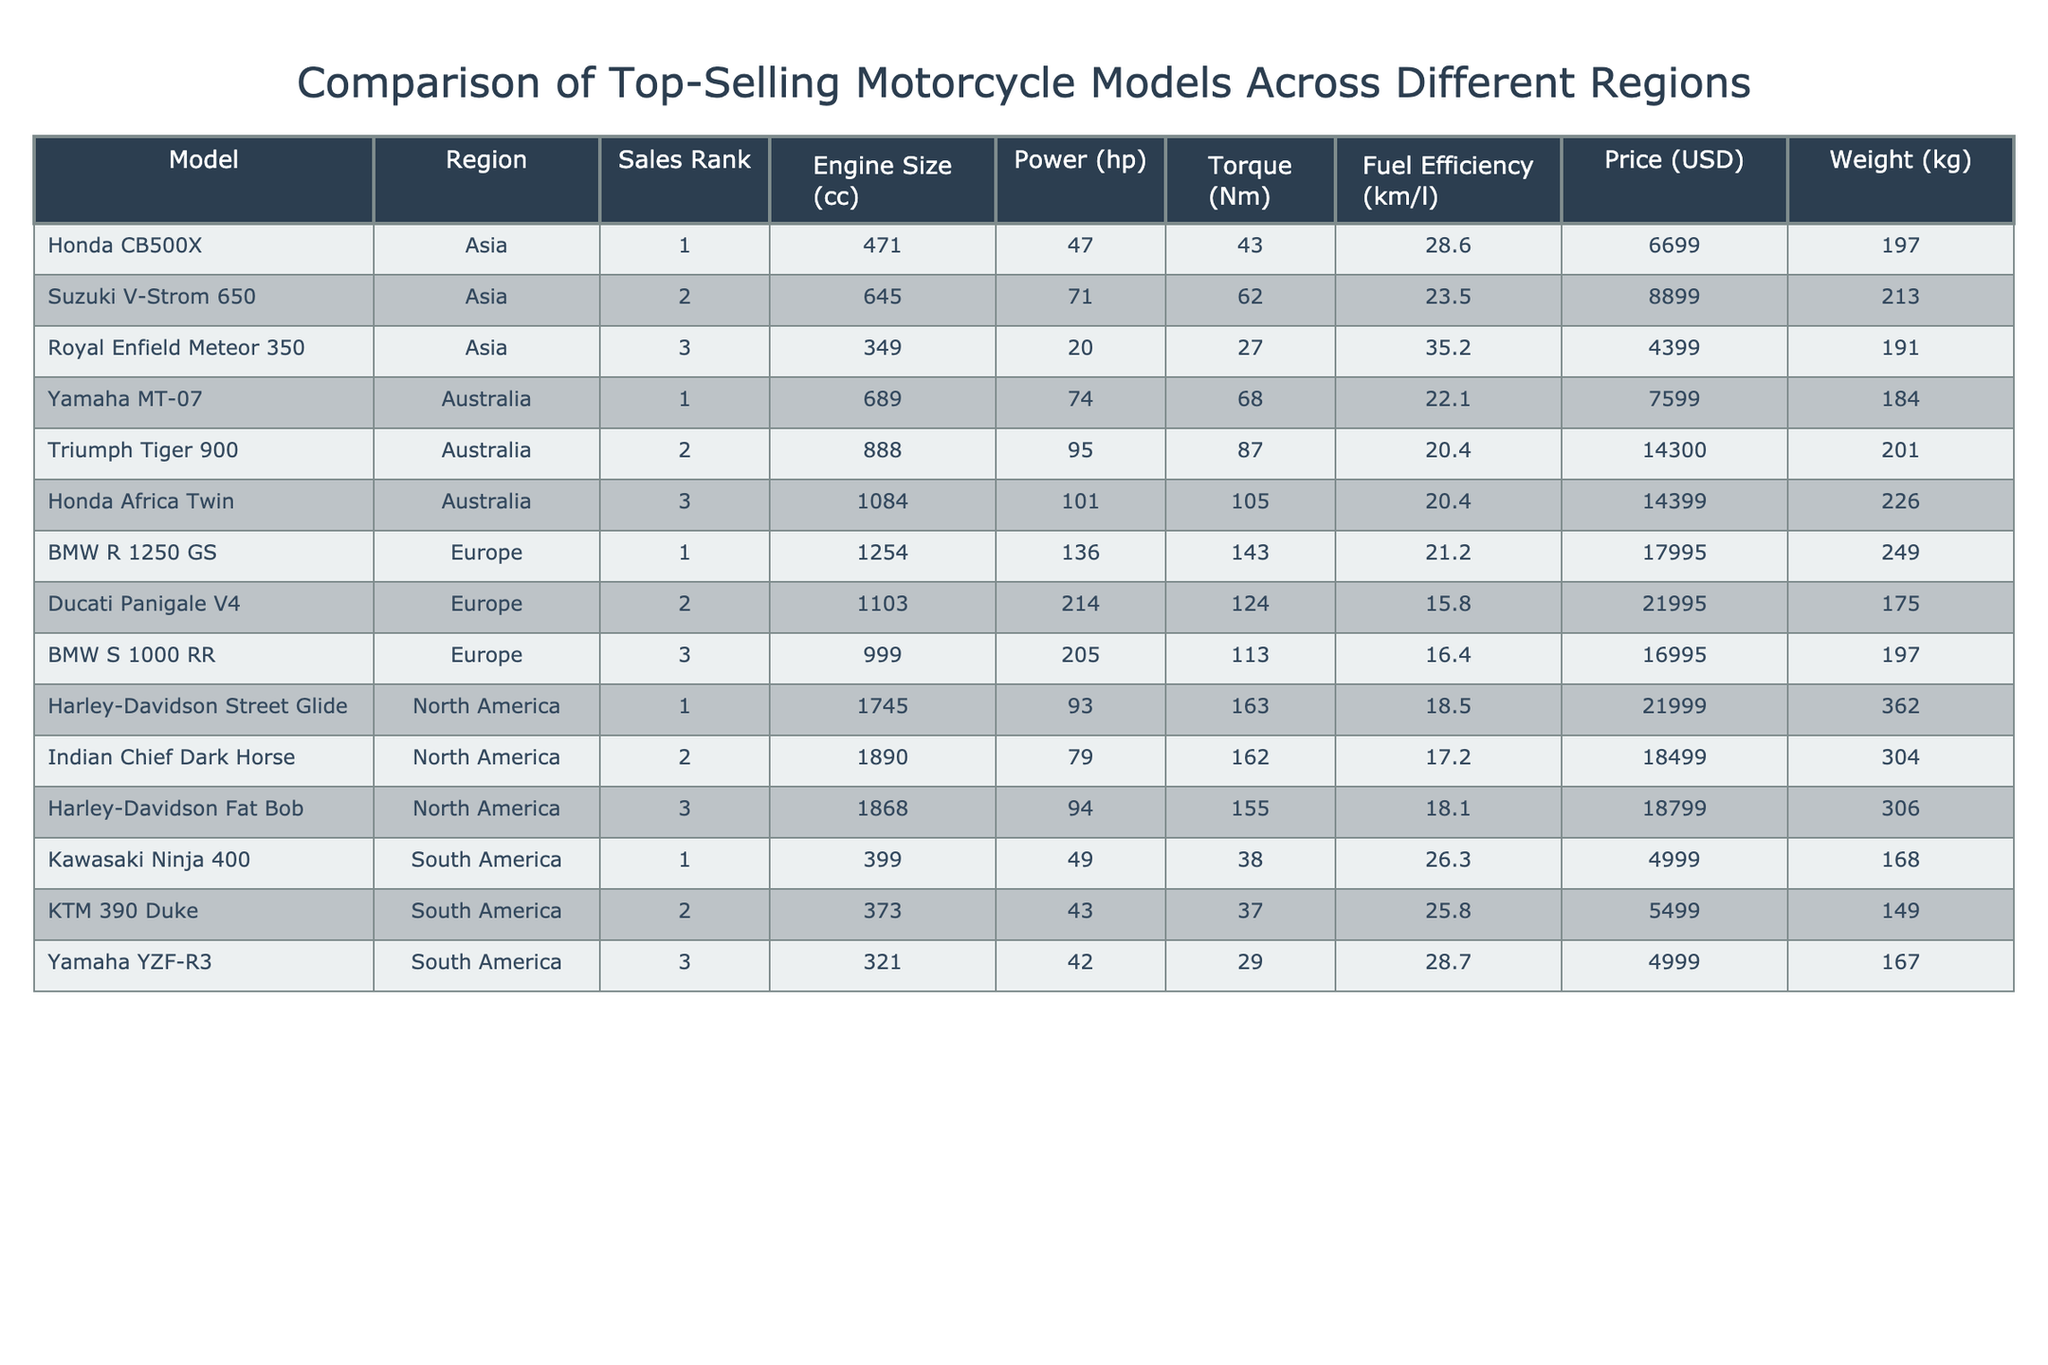What is the engine size of the BMW R 1250 GS? The table lists the BMW R 1250 GS under the Europe region, where its engine size is provided. By locating this model and looking at the engine size column, we can see that it is 1254 cc.
Answer: 1254 cc Which motorcycle has the highest power output in the table? By scanning through the power HP column, we need to find the maximum value. The Ducati Panigale V4 shows a power output of 214 hp, higher than any other model listed.
Answer: 214 hp How many motorcycles have a fuel efficiency greater than 20 km/l? To find this, we need to count the entries in the Fuel Efficiency column greater than 20 km/l. The following motorcycles qualify: BMW R 1250 GS, Honda CB500X, Yamaha MT-07, Suzuki V-Strom 650, Triumph Tiger 900, and Honda Africa Twin. This makes six entries in total.
Answer: 6 Is the Honda CB500X the most fuel-efficient model in Asia? The table indicates that the Honda CB500X has a fuel efficiency of 28.6 km/l. When comparing this value with the Royal Enfield Meteor 350, which has a fuel efficiency of 35.2 km/l, we find that the Royal Enfield is more fuel-efficient. Therefore, the statement is false.
Answer: No What is the weight difference between the heaviest and lightest motorcycle models in the table? First, we find the heaviest model by reviewing the weight column, where the Harley-Davidson Street Glide weighs 362 kg, and the lightest model is the KTM 390 Duke at 149 kg. To find the difference, we subtract the weight of the lighter model from the heavier one: 362 kg - 149 kg = 213 kg.
Answer: 213 kg 